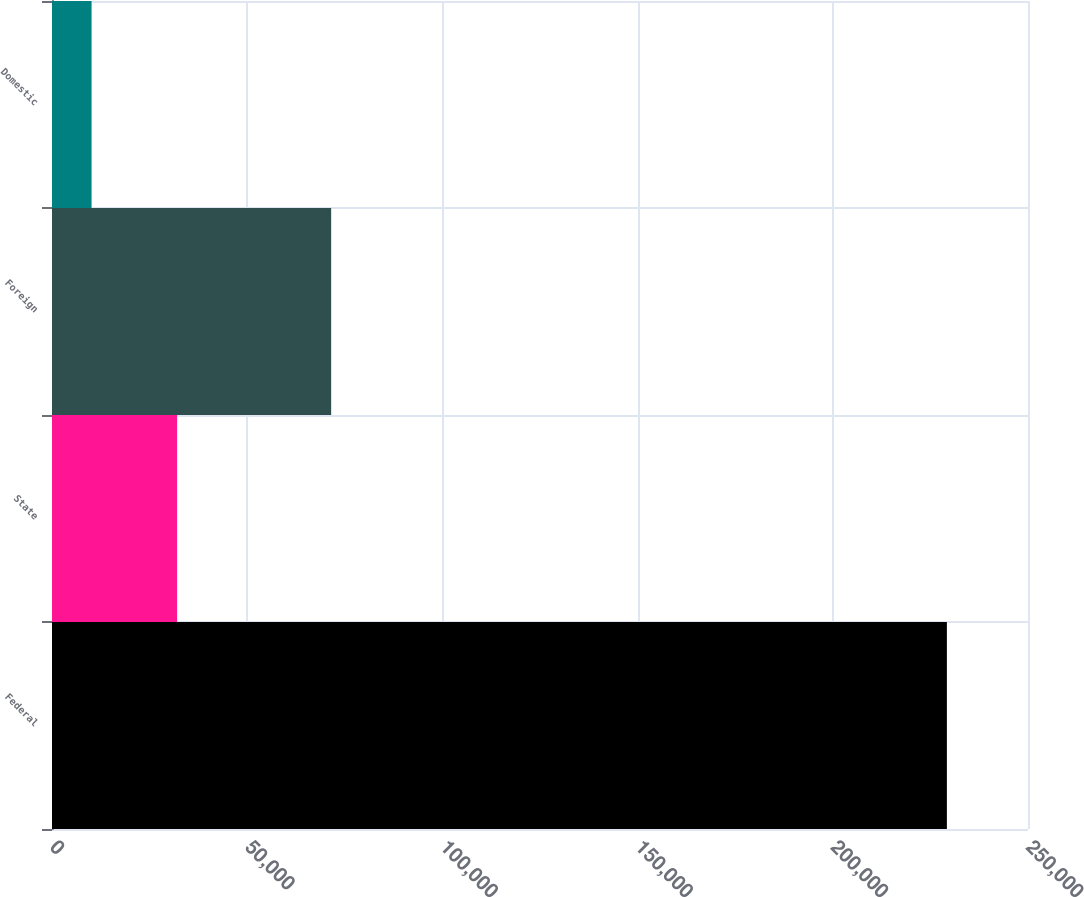<chart> <loc_0><loc_0><loc_500><loc_500><bar_chart><fcel>Federal<fcel>State<fcel>Foreign<fcel>Domestic<nl><fcel>229224<fcel>32043<fcel>71507<fcel>10134<nl></chart> 